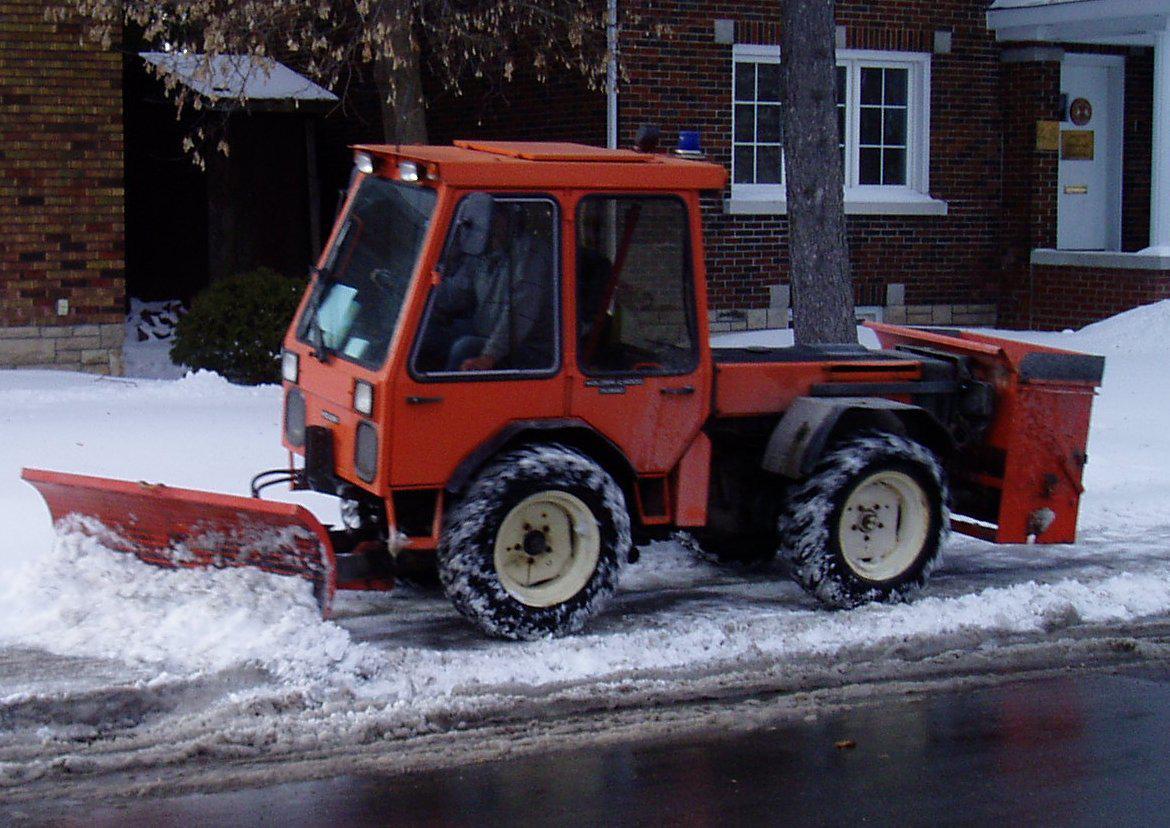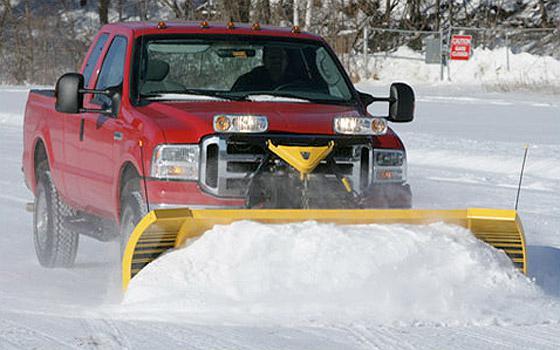The first image is the image on the left, the second image is the image on the right. Assess this claim about the two images: "At least one snowplow is not yellow.". Correct or not? Answer yes or no. Yes. 